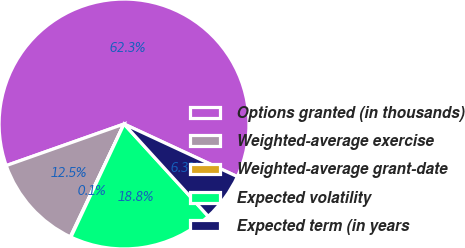<chart> <loc_0><loc_0><loc_500><loc_500><pie_chart><fcel>Options granted (in thousands)<fcel>Weighted-average exercise<fcel>Weighted-average grant-date<fcel>Expected volatility<fcel>Expected term (in years<nl><fcel>62.32%<fcel>12.53%<fcel>0.08%<fcel>18.76%<fcel>6.31%<nl></chart> 